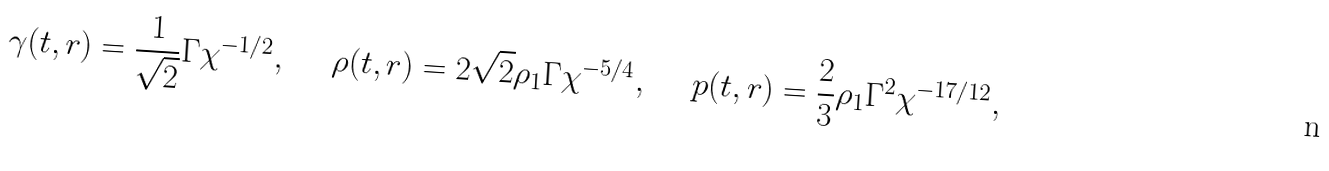<formula> <loc_0><loc_0><loc_500><loc_500>\gamma ( t , r ) = \frac { 1 } { \sqrt { 2 } } \Gamma \chi ^ { - 1 / 2 } , \quad \ \rho ( t , r ) = 2 \sqrt { 2 } \rho _ { 1 } \Gamma \chi ^ { - 5 / 4 } , \quad \ p ( t , r ) = \frac { 2 } { 3 } \rho _ { 1 } \Gamma ^ { 2 } \chi ^ { - 1 7 / 1 2 } ,</formula> 